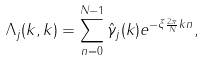<formula> <loc_0><loc_0><loc_500><loc_500>\Lambda _ { j } ( k , k ) = \sum _ { n = 0 } ^ { N - 1 } \hat { \gamma } _ { j } ( k ) e ^ { - \xi \frac { 2 \pi } { N } k n } ,</formula> 